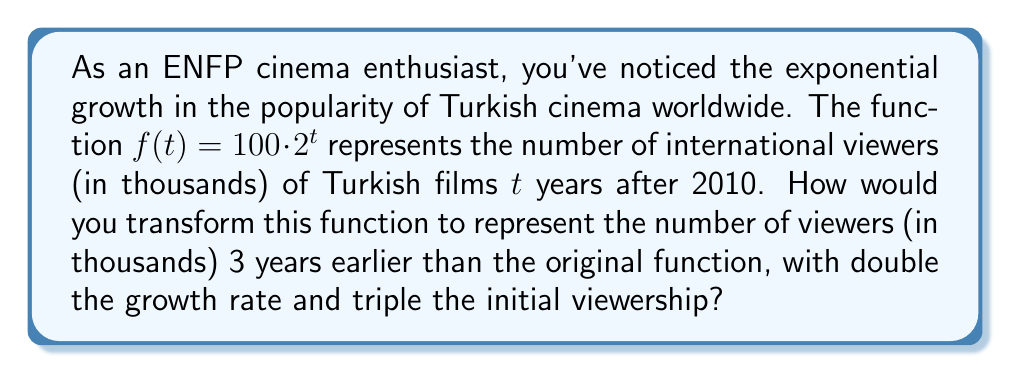What is the answer to this math problem? Let's break this down step-by-step:

1) The original function is $f(t) = 100 \cdot 2^t$

2) To shift the function 3 years earlier, we replace $t$ with $(t+3)$:
   $g(t) = 100 \cdot 2^{(t+3)}$

3) To double the growth rate, we replace the base 2 with $2^2 = 4$:
   $h(t) = 100 \cdot 4^{(t+3)}$

4) To triple the initial viewership, we multiply the entire function by 3:
   $k(t) = 3 \cdot 100 \cdot 4^{(t+3)}$

5) Simplify:
   $k(t) = 300 \cdot 4^{(t+3)}$

6) We can further simplify by expanding $4^{(t+3)}$:
   $k(t) = 300 \cdot 4^t \cdot 4^3$
   $k(t) = 300 \cdot 64 \cdot 4^t$
   $k(t) = 19200 \cdot 4^t$

Thus, the final transformed function is $k(t) = 19200 \cdot 4^t$.
Answer: $k(t) = 19200 \cdot 4^t$ 